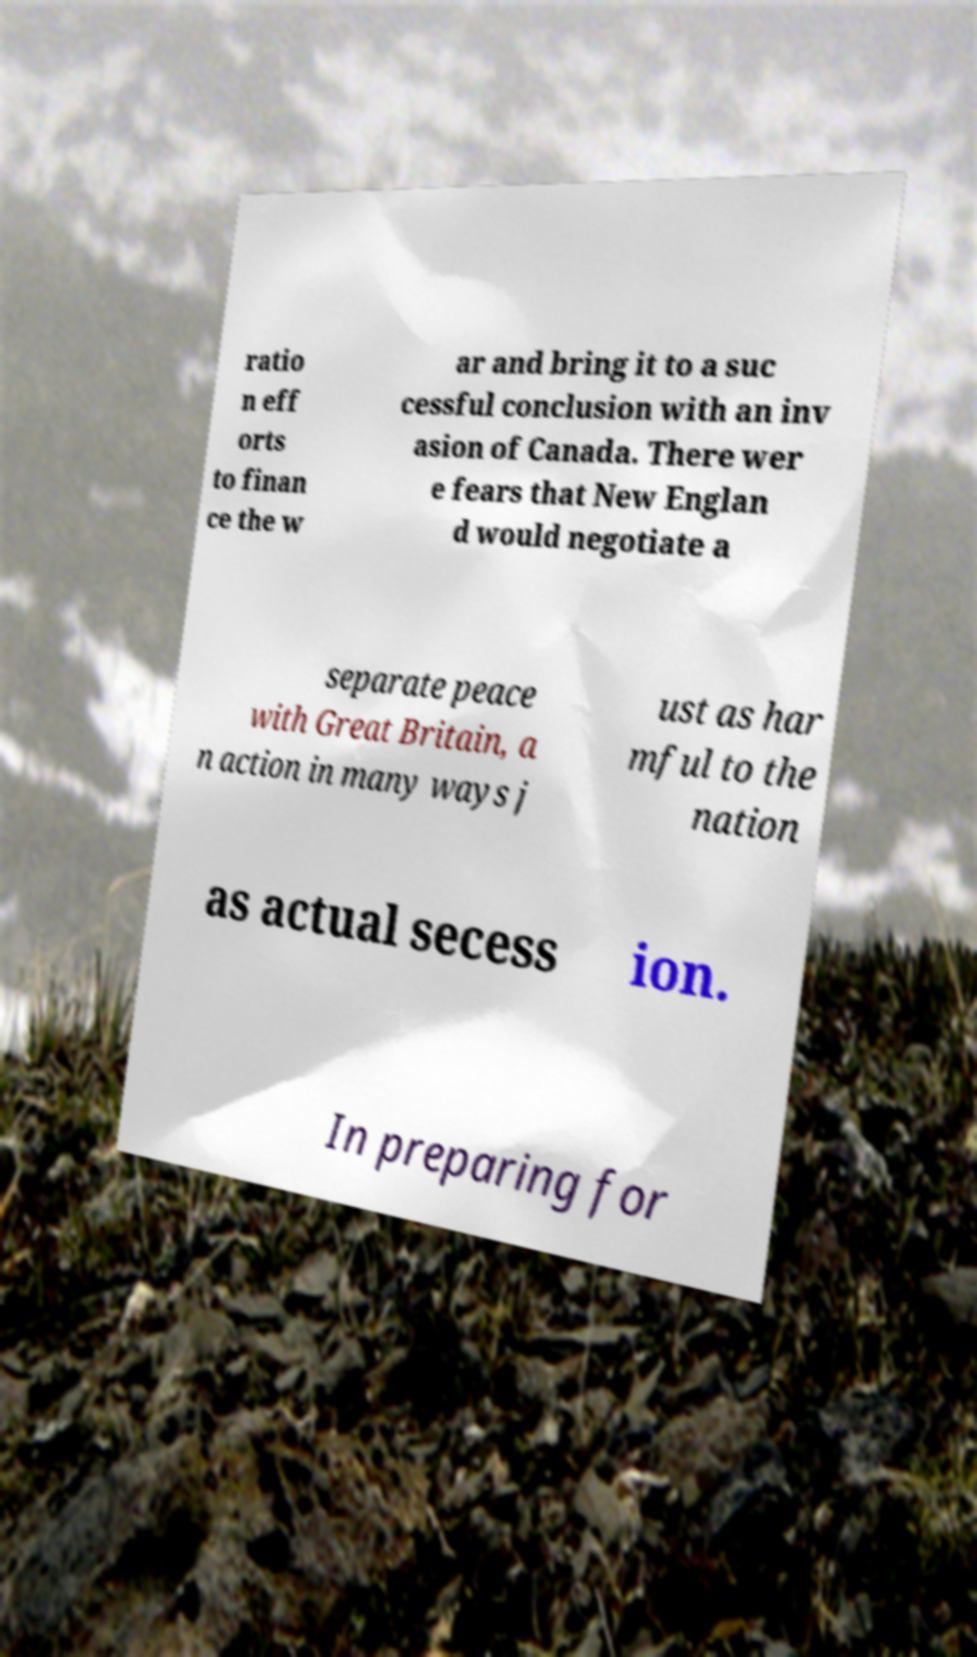Could you extract and type out the text from this image? ratio n eff orts to finan ce the w ar and bring it to a suc cessful conclusion with an inv asion of Canada. There wer e fears that New Englan d would negotiate a separate peace with Great Britain, a n action in many ways j ust as har mful to the nation as actual secess ion. In preparing for 